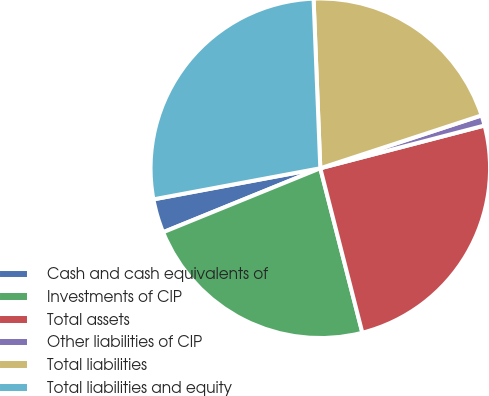<chart> <loc_0><loc_0><loc_500><loc_500><pie_chart><fcel>Cash and cash equivalents of<fcel>Investments of CIP<fcel>Total assets<fcel>Other liabilities of CIP<fcel>Total liabilities<fcel>Total liabilities and equity<nl><fcel>3.22%<fcel>22.83%<fcel>25.07%<fcel>0.99%<fcel>20.59%<fcel>27.3%<nl></chart> 